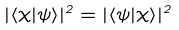Convert formula to latex. <formula><loc_0><loc_0><loc_500><loc_500>| \langle \chi | \psi \rangle | ^ { 2 } = | \langle \psi | \chi \rangle | ^ { 2 }</formula> 